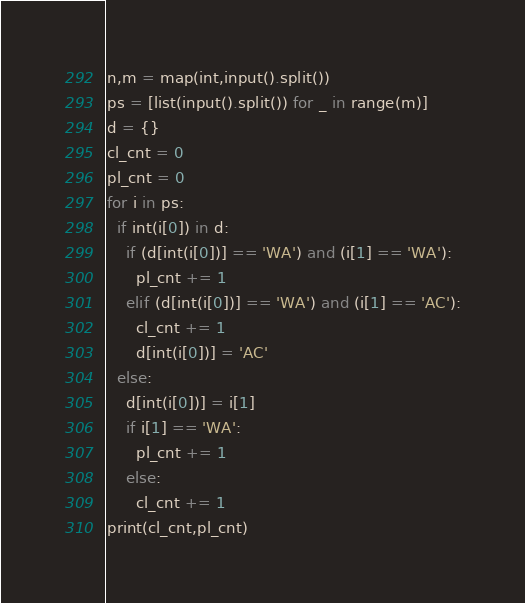Convert code to text. <code><loc_0><loc_0><loc_500><loc_500><_Python_>n,m = map(int,input().split())
ps = [list(input().split()) for _ in range(m)]
d = {}
cl_cnt = 0
pl_cnt = 0
for i in ps:
  if int(i[0]) in d:
    if (d[int(i[0])] == 'WA') and (i[1] == 'WA'):
      pl_cnt += 1
    elif (d[int(i[0])] == 'WA') and (i[1] == 'AC'):
      cl_cnt += 1
      d[int(i[0])] = 'AC'
  else:
    d[int(i[0])] = i[1]
    if i[1] == 'WA':
      pl_cnt += 1
    else:
      cl_cnt += 1
print(cl_cnt,pl_cnt)</code> 